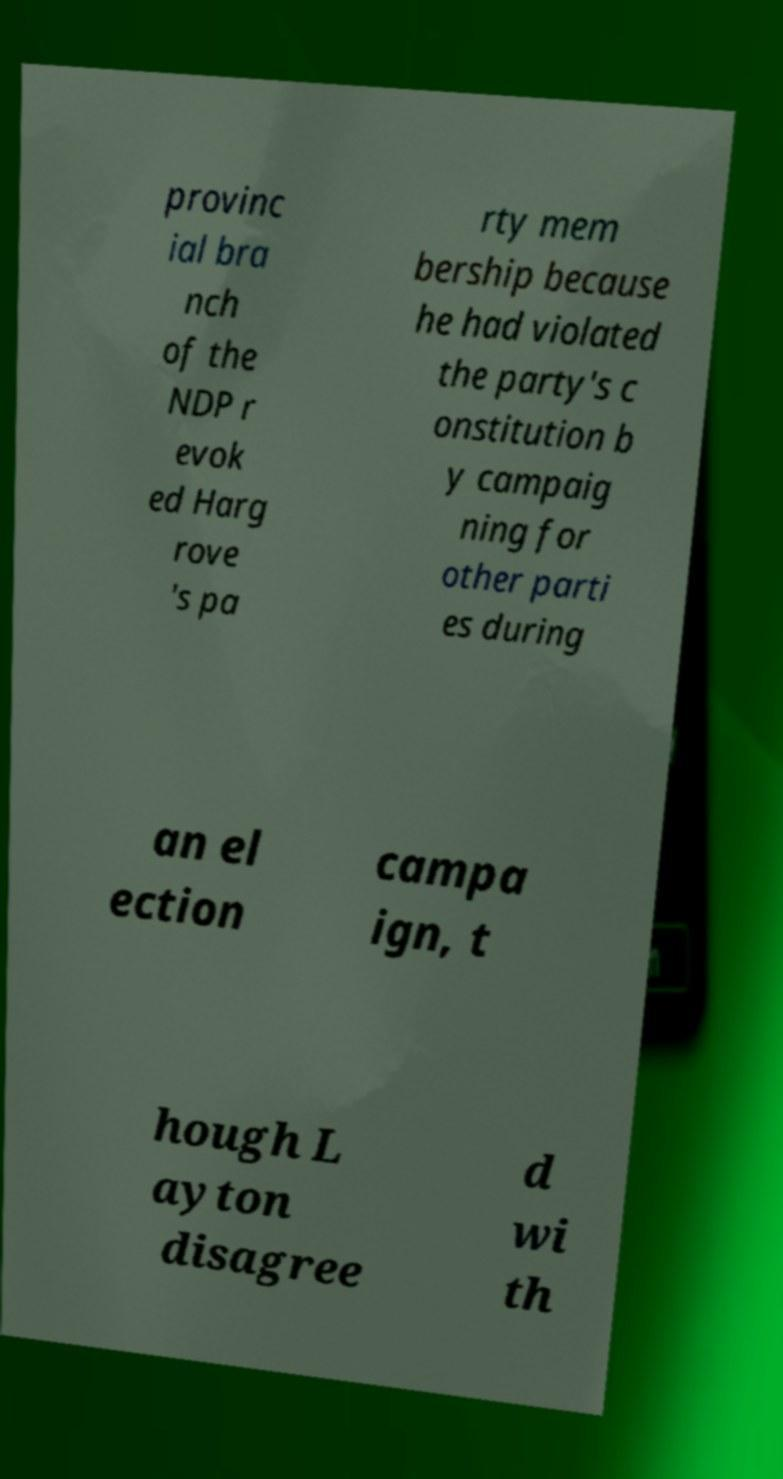Can you read and provide the text displayed in the image?This photo seems to have some interesting text. Can you extract and type it out for me? provinc ial bra nch of the NDP r evok ed Harg rove 's pa rty mem bership because he had violated the party's c onstitution b y campaig ning for other parti es during an el ection campa ign, t hough L ayton disagree d wi th 